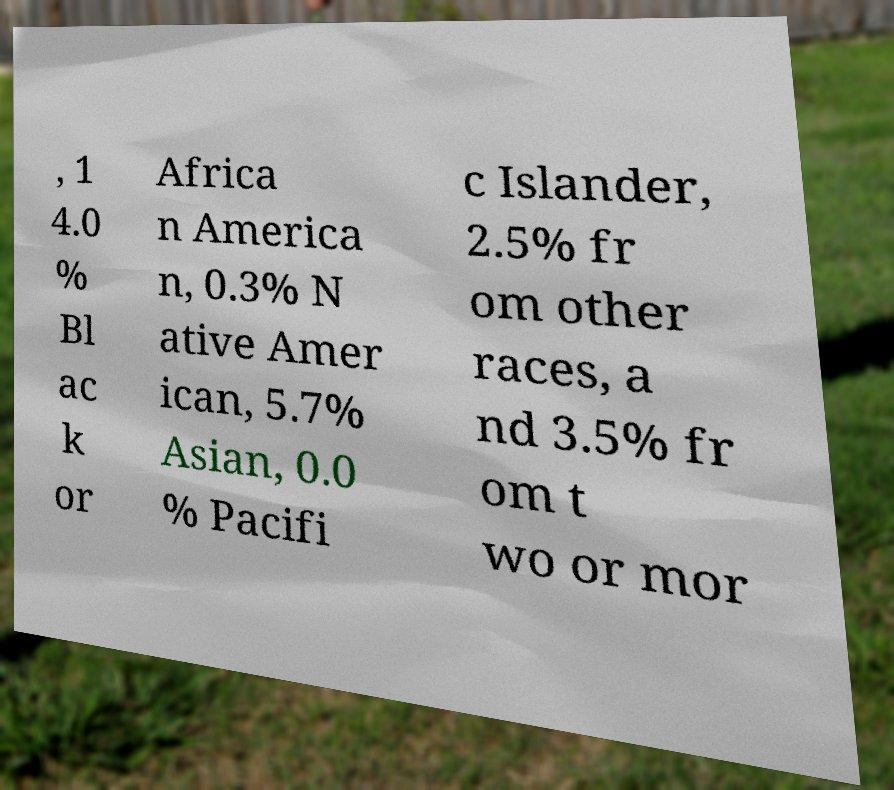There's text embedded in this image that I need extracted. Can you transcribe it verbatim? , 1 4.0 % Bl ac k or Africa n America n, 0.3% N ative Amer ican, 5.7% Asian, 0.0 % Pacifi c Islander, 2.5% fr om other races, a nd 3.5% fr om t wo or mor 